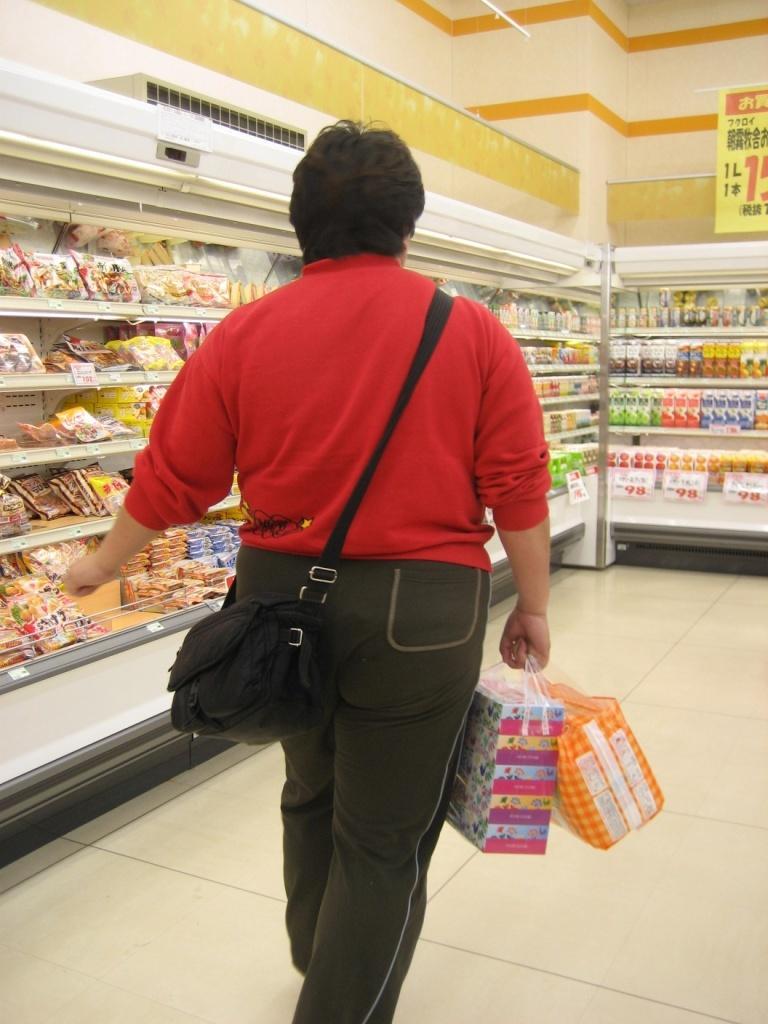Can you describe this image briefly? There is one person walking and wearing a red color t shirt and a bag, and holding two covers in the middle of this image. There are some drink items and food items are kept in a different racks as we can see in the background. There is a wall at the top of this image, and there is a floor at the bottom of this image. 